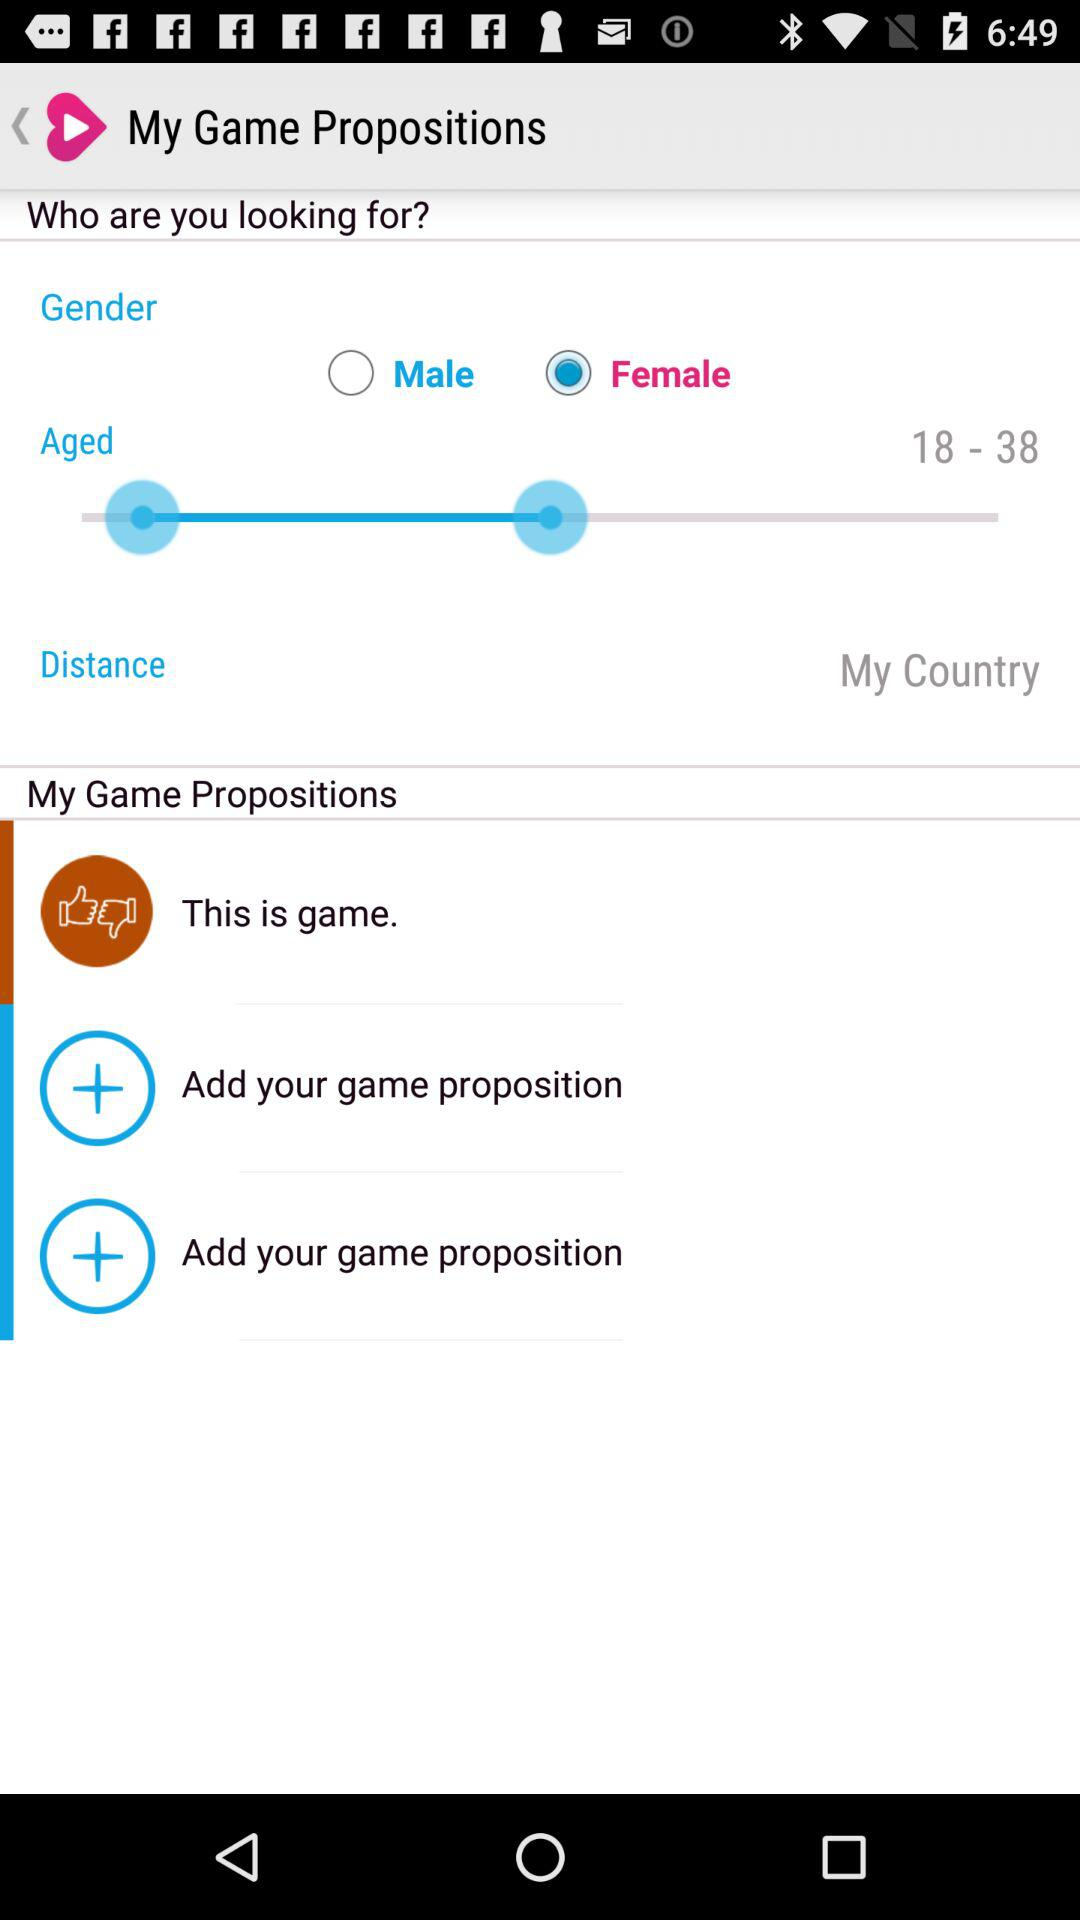How many more years are there in the 'Aged' range than in the 'Distance' range?
Answer the question using a single word or phrase. 20 